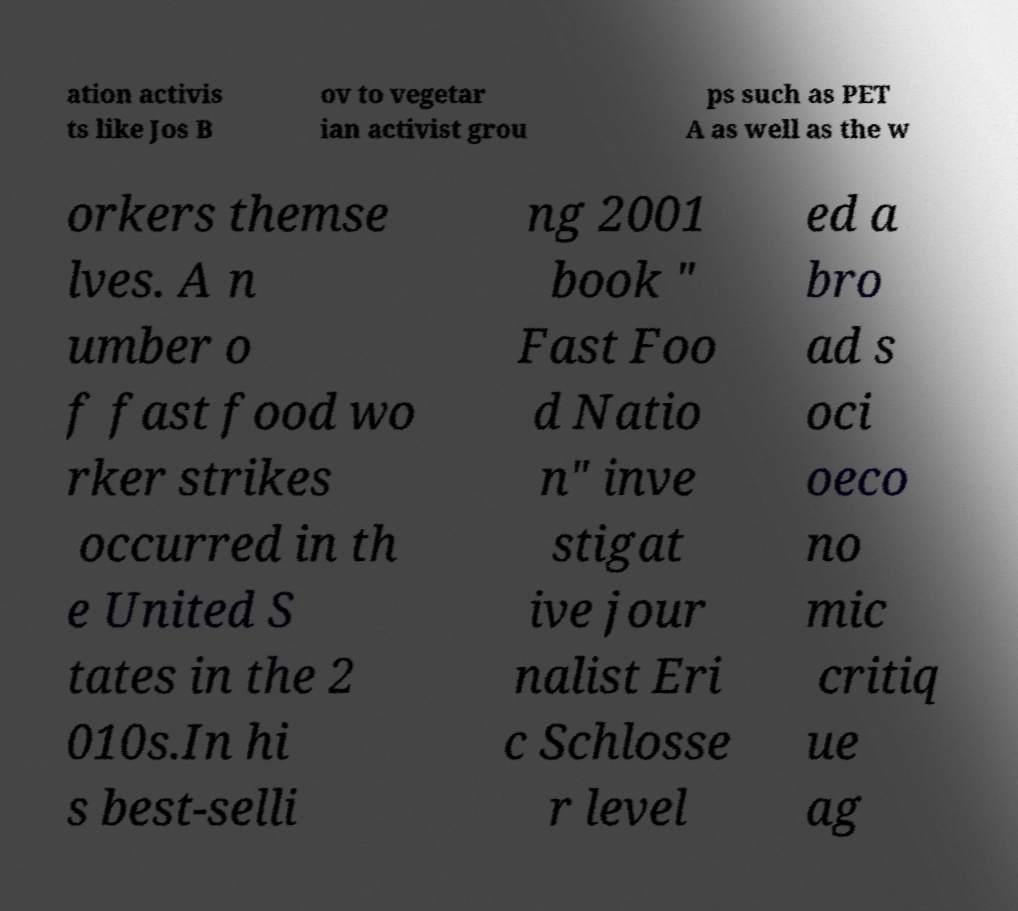Could you assist in decoding the text presented in this image and type it out clearly? ation activis ts like Jos B ov to vegetar ian activist grou ps such as PET A as well as the w orkers themse lves. A n umber o f fast food wo rker strikes occurred in th e United S tates in the 2 010s.In hi s best-selli ng 2001 book " Fast Foo d Natio n" inve stigat ive jour nalist Eri c Schlosse r level ed a bro ad s oci oeco no mic critiq ue ag 